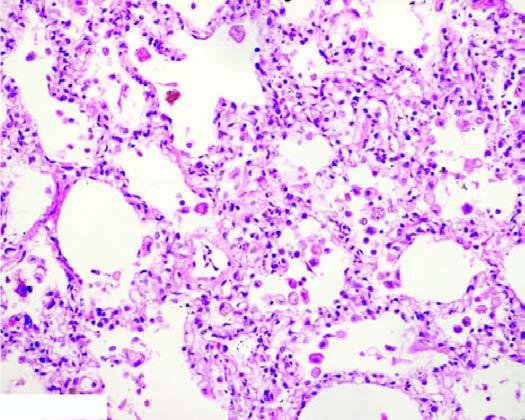what do the alveolar lumina contain failure cells alveolar macrophages containing haemosiderin pigment?
Answer the question using a single word or phrase. Heart failure cells (alveolar macrophages containing haemosiderin pigment) 